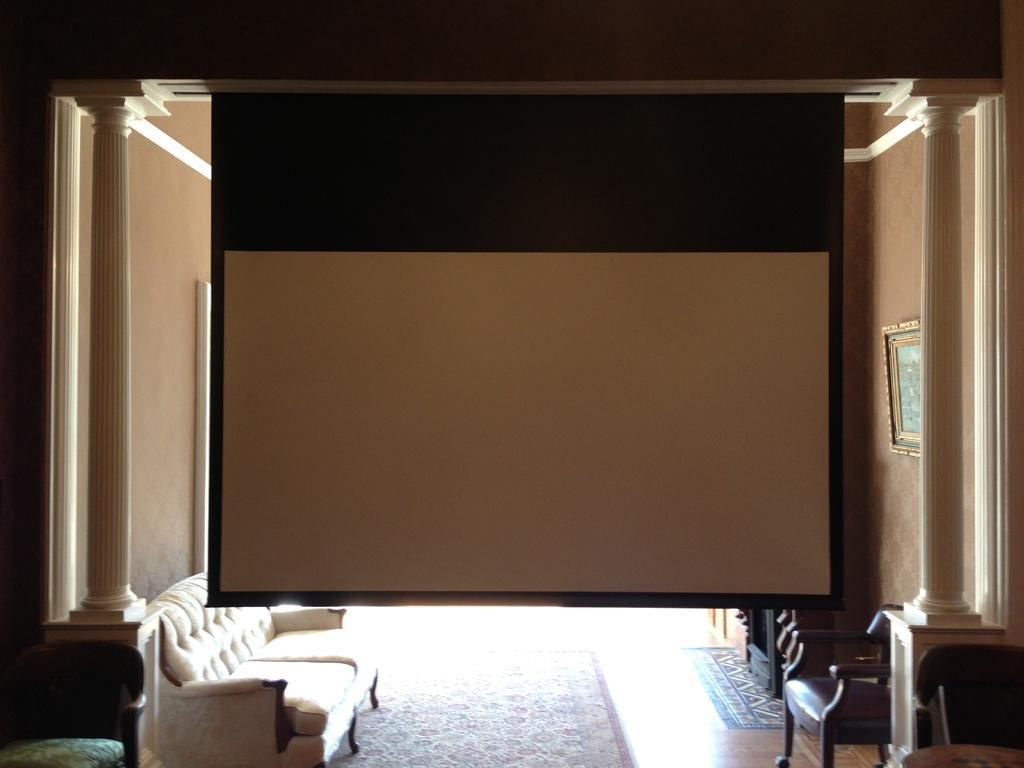How would you summarize this image in a sentence or two? In this image I can see a sofa, few chairs and projector screen. On this wall I can see a frame. 